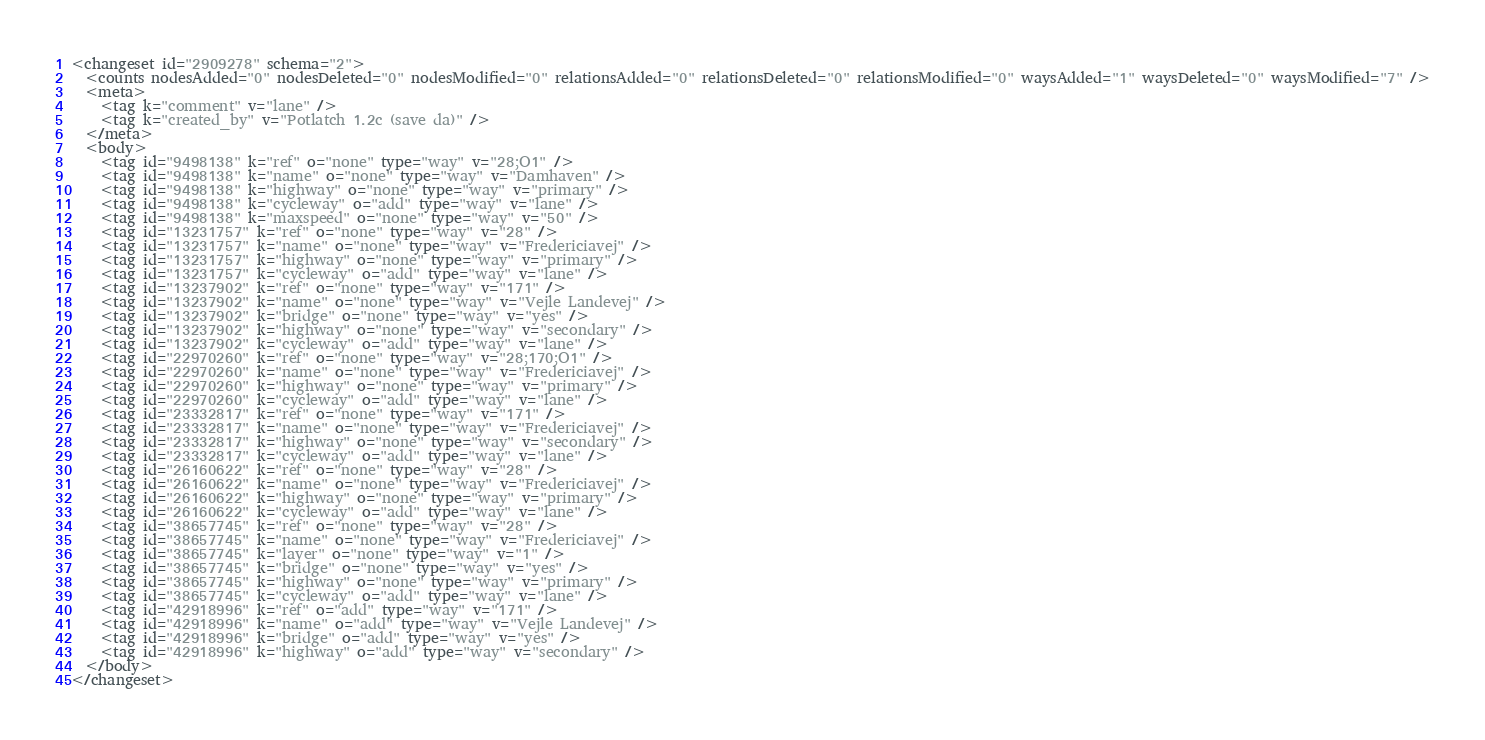Convert code to text. <code><loc_0><loc_0><loc_500><loc_500><_XML_><changeset id="2909278" schema="2">
  <counts nodesAdded="0" nodesDeleted="0" nodesModified="0" relationsAdded="0" relationsDeleted="0" relationsModified="0" waysAdded="1" waysDeleted="0" waysModified="7" />
  <meta>
    <tag k="comment" v="lane" />
    <tag k="created_by" v="Potlatch 1.2c (save da)" />
  </meta>
  <body>
    <tag id="9498138" k="ref" o="none" type="way" v="28;O1" />
    <tag id="9498138" k="name" o="none" type="way" v="Damhaven" />
    <tag id="9498138" k="highway" o="none" type="way" v="primary" />
    <tag id="9498138" k="cycleway" o="add" type="way" v="lane" />
    <tag id="9498138" k="maxspeed" o="none" type="way" v="50" />
    <tag id="13231757" k="ref" o="none" type="way" v="28" />
    <tag id="13231757" k="name" o="none" type="way" v="Fredericiavej" />
    <tag id="13231757" k="highway" o="none" type="way" v="primary" />
    <tag id="13231757" k="cycleway" o="add" type="way" v="lane" />
    <tag id="13237902" k="ref" o="none" type="way" v="171" />
    <tag id="13237902" k="name" o="none" type="way" v="Vejle Landevej" />
    <tag id="13237902" k="bridge" o="none" type="way" v="yes" />
    <tag id="13237902" k="highway" o="none" type="way" v="secondary" />
    <tag id="13237902" k="cycleway" o="add" type="way" v="lane" />
    <tag id="22970260" k="ref" o="none" type="way" v="28;170;O1" />
    <tag id="22970260" k="name" o="none" type="way" v="Fredericiavej" />
    <tag id="22970260" k="highway" o="none" type="way" v="primary" />
    <tag id="22970260" k="cycleway" o="add" type="way" v="lane" />
    <tag id="23332817" k="ref" o="none" type="way" v="171" />
    <tag id="23332817" k="name" o="none" type="way" v="Fredericiavej" />
    <tag id="23332817" k="highway" o="none" type="way" v="secondary" />
    <tag id="23332817" k="cycleway" o="add" type="way" v="lane" />
    <tag id="26160622" k="ref" o="none" type="way" v="28" />
    <tag id="26160622" k="name" o="none" type="way" v="Fredericiavej" />
    <tag id="26160622" k="highway" o="none" type="way" v="primary" />
    <tag id="26160622" k="cycleway" o="add" type="way" v="lane" />
    <tag id="38657745" k="ref" o="none" type="way" v="28" />
    <tag id="38657745" k="name" o="none" type="way" v="Fredericiavej" />
    <tag id="38657745" k="layer" o="none" type="way" v="1" />
    <tag id="38657745" k="bridge" o="none" type="way" v="yes" />
    <tag id="38657745" k="highway" o="none" type="way" v="primary" />
    <tag id="38657745" k="cycleway" o="add" type="way" v="lane" />
    <tag id="42918996" k="ref" o="add" type="way" v="171" />
    <tag id="42918996" k="name" o="add" type="way" v="Vejle Landevej" />
    <tag id="42918996" k="bridge" o="add" type="way" v="yes" />
    <tag id="42918996" k="highway" o="add" type="way" v="secondary" />
  </body>
</changeset>
</code> 